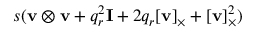<formula> <loc_0><loc_0><loc_500><loc_500>s ( v \otimes v + q _ { r } ^ { 2 } I + 2 q _ { r } [ v ] _ { \times } + [ v ] _ { \times } ^ { 2 } )</formula> 